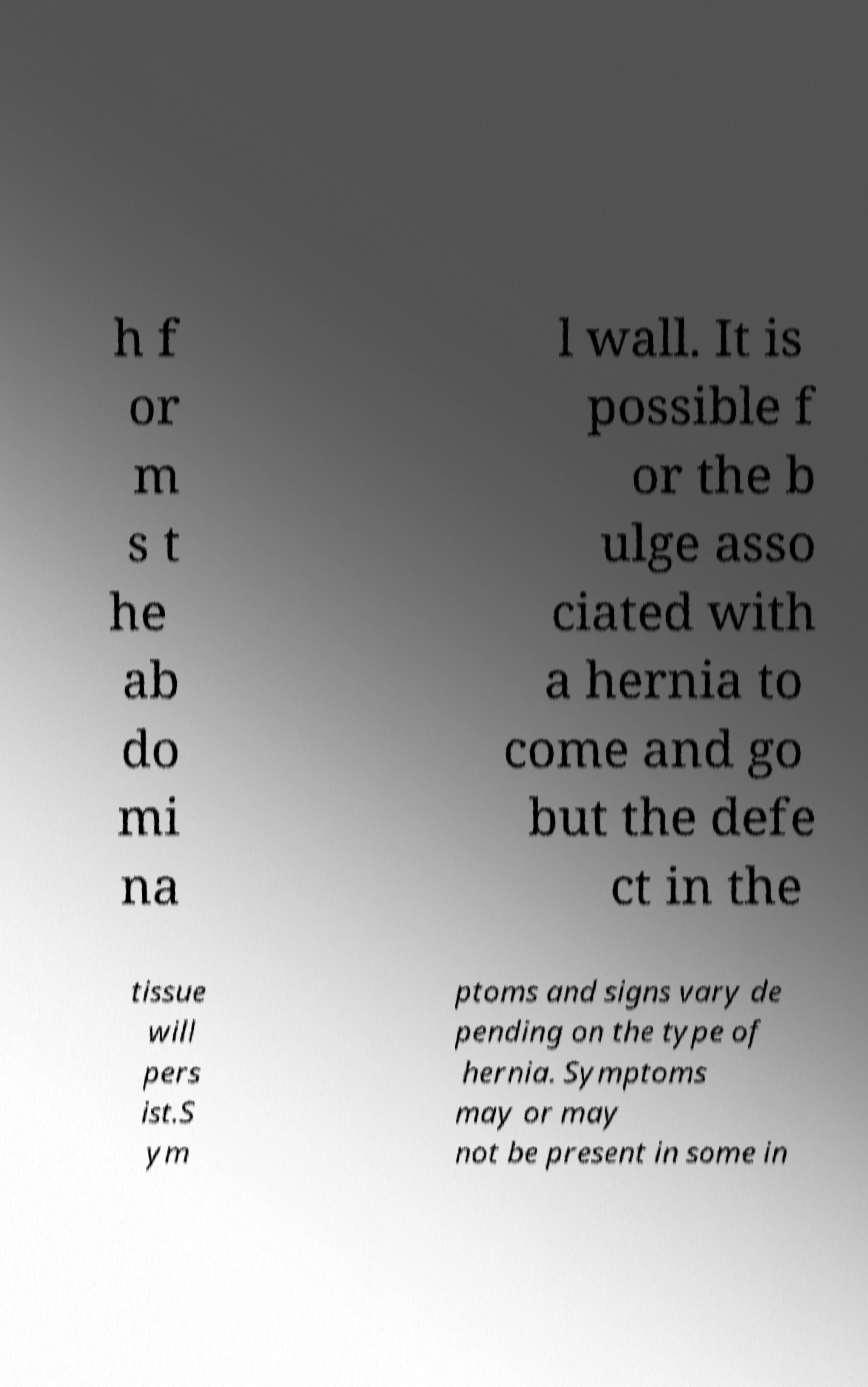Can you read and provide the text displayed in the image?This photo seems to have some interesting text. Can you extract and type it out for me? h f or m s t he ab do mi na l wall. It is possible f or the b ulge asso ciated with a hernia to come and go but the defe ct in the tissue will pers ist.S ym ptoms and signs vary de pending on the type of hernia. Symptoms may or may not be present in some in 